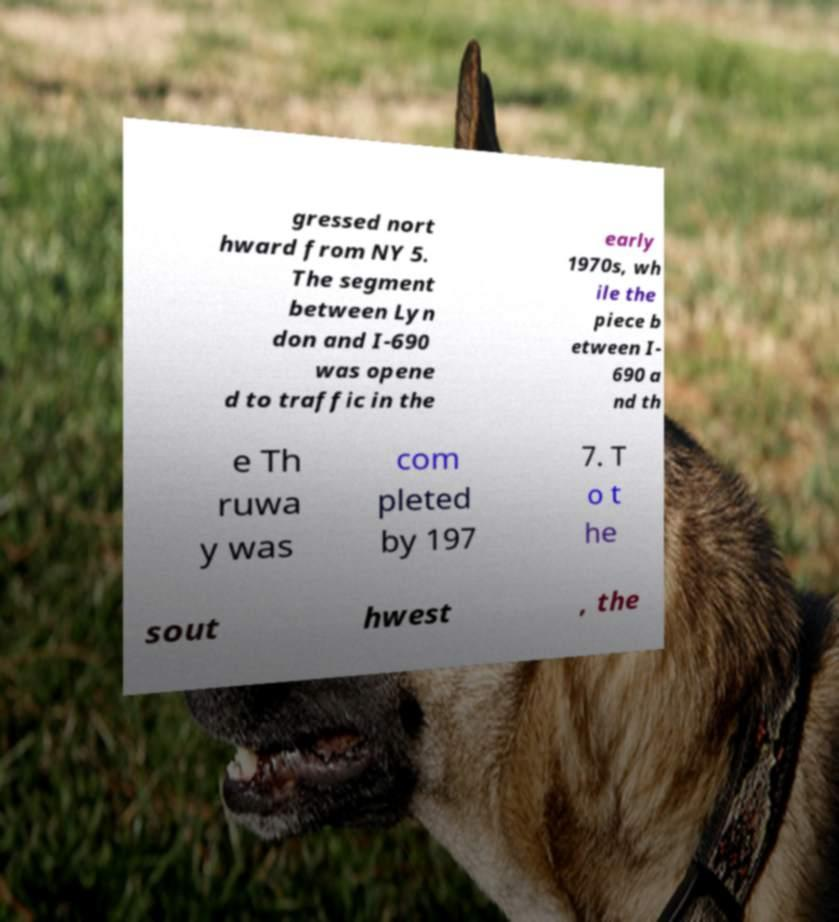What messages or text are displayed in this image? I need them in a readable, typed format. gressed nort hward from NY 5. The segment between Lyn don and I-690 was opene d to traffic in the early 1970s, wh ile the piece b etween I- 690 a nd th e Th ruwa y was com pleted by 197 7. T o t he sout hwest , the 